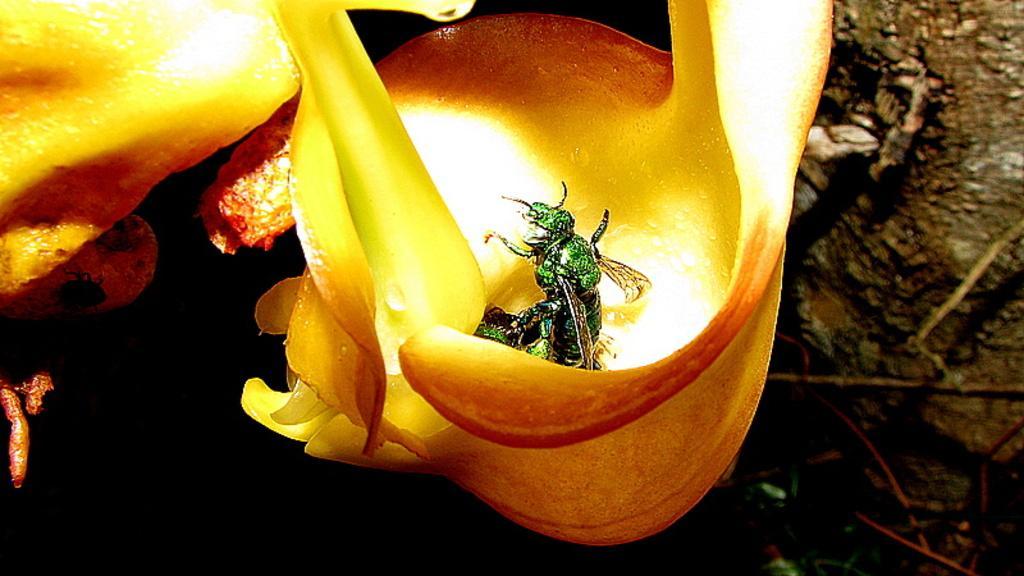Could you give a brief overview of what you see in this image? In the middle of this image, there is an insect on a petal of a yellow color flower. And the background is dark in color. 